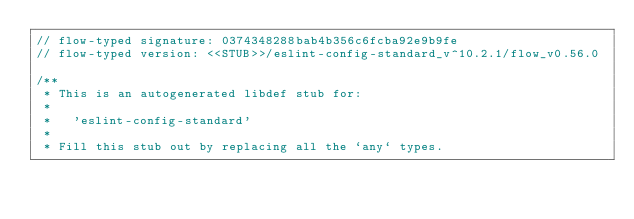Convert code to text. <code><loc_0><loc_0><loc_500><loc_500><_JavaScript_>// flow-typed signature: 0374348288bab4b356c6fcba92e9b9fe
// flow-typed version: <<STUB>>/eslint-config-standard_v^10.2.1/flow_v0.56.0

/**
 * This is an autogenerated libdef stub for:
 *
 *   'eslint-config-standard'
 *
 * Fill this stub out by replacing all the `any` types.</code> 